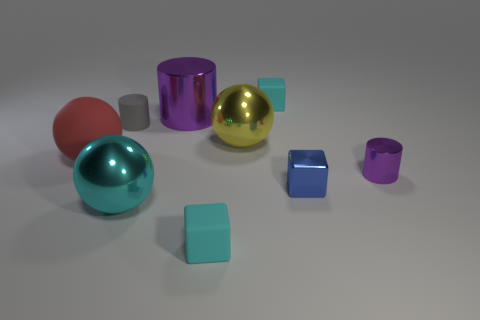Do the big metal cylinder and the shiny cylinder that is in front of the gray thing have the same color?
Your answer should be very brief. Yes. Is there a metallic object that has the same color as the tiny metallic cylinder?
Your answer should be compact. Yes. What is the material of the small cylinder that is the same color as the large metal cylinder?
Provide a succinct answer. Metal. Do the small cube in front of the blue metallic object and the large ball that is in front of the small blue metal thing have the same color?
Provide a short and direct response. Yes. The large metallic object that is the same color as the small shiny cylinder is what shape?
Give a very brief answer. Cylinder. There is a block that is to the left of the tiny blue shiny thing and behind the large cyan thing; what material is it?
Ensure brevity in your answer.  Rubber. What is the shape of the large matte object in front of the tiny cyan object that is behind the blue metal block?
Make the answer very short. Sphere. Is the big shiny cylinder the same color as the metal block?
Make the answer very short. No. How many cyan things are either large rubber objects or tiny rubber cylinders?
Your response must be concise. 0. Are there any small metallic things behind the small gray rubber object?
Offer a very short reply. No. 